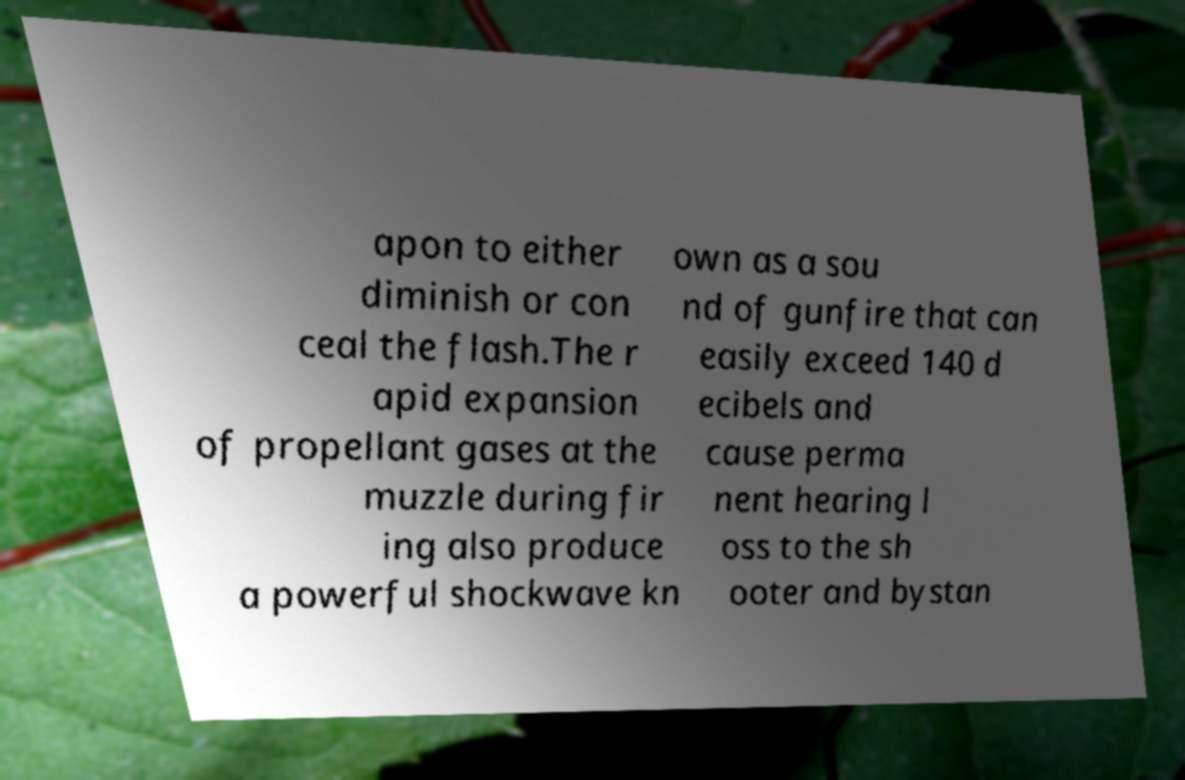Could you extract and type out the text from this image? apon to either diminish or con ceal the flash.The r apid expansion of propellant gases at the muzzle during fir ing also produce a powerful shockwave kn own as a sou nd of gunfire that can easily exceed 140 d ecibels and cause perma nent hearing l oss to the sh ooter and bystan 